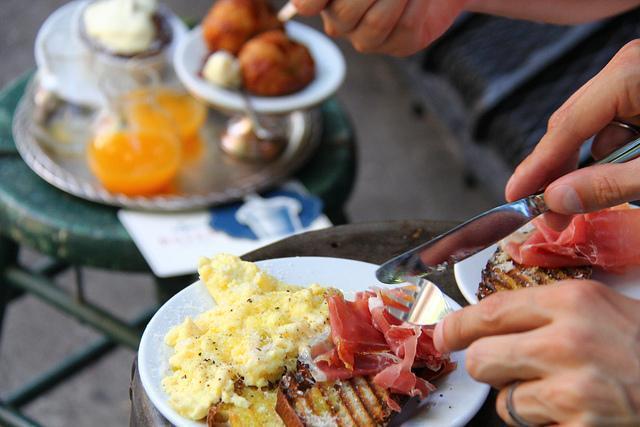How many fried eggs can be seen?
Give a very brief answer. 0. How many people are there?
Give a very brief answer. 2. How many bowls are visible?
Give a very brief answer. 2. 